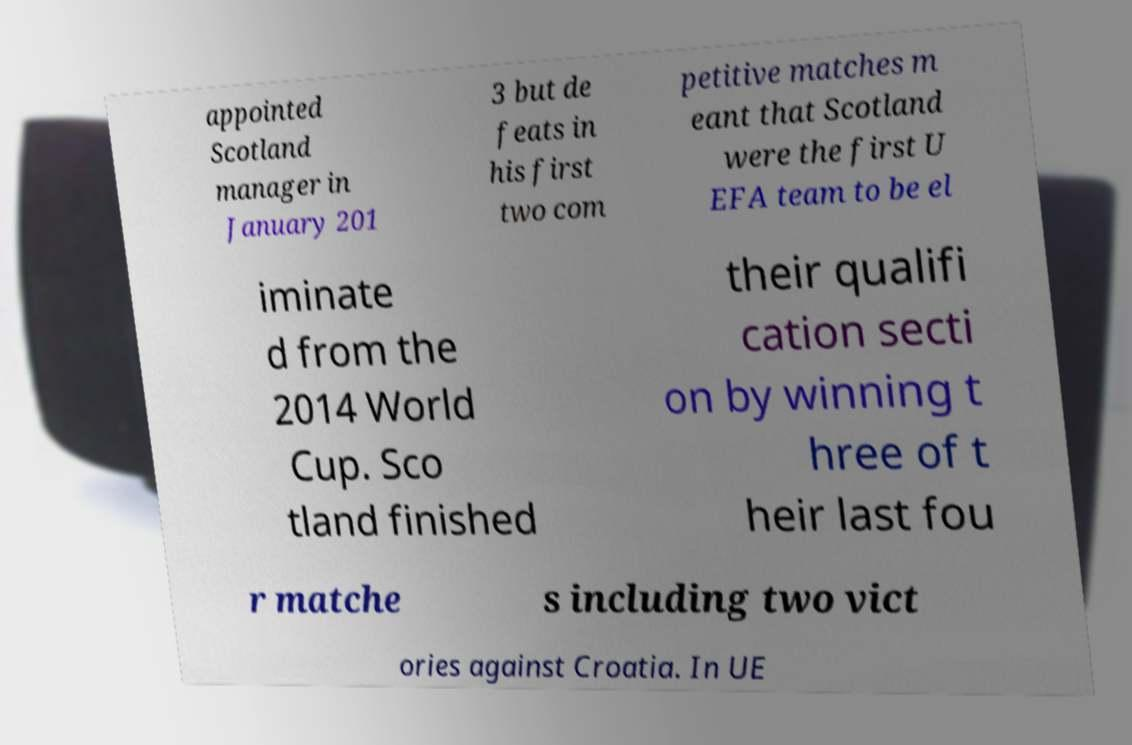Can you read and provide the text displayed in the image?This photo seems to have some interesting text. Can you extract and type it out for me? appointed Scotland manager in January 201 3 but de feats in his first two com petitive matches m eant that Scotland were the first U EFA team to be el iminate d from the 2014 World Cup. Sco tland finished their qualifi cation secti on by winning t hree of t heir last fou r matche s including two vict ories against Croatia. In UE 